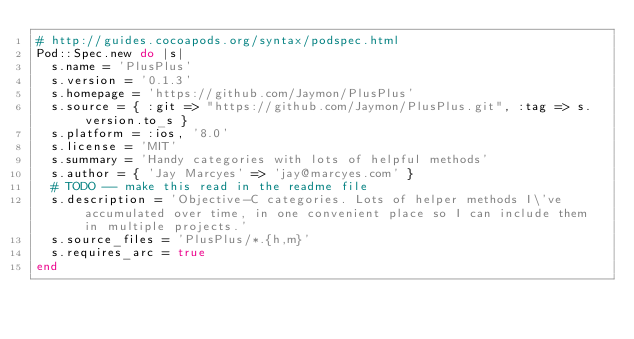<code> <loc_0><loc_0><loc_500><loc_500><_Ruby_># http://guides.cocoapods.org/syntax/podspec.html
Pod::Spec.new do |s|
  s.name = 'PlusPlus'
  s.version = '0.1.3'
  s.homepage = 'https://github.com/Jaymon/PlusPlus'
  s.source = { :git => "https://github.com/Jaymon/PlusPlus.git", :tag => s.version.to_s }
  s.platform = :ios, '8.0'
  s.license = 'MIT'
  s.summary = 'Handy categories with lots of helpful methods'
  s.author = { 'Jay Marcyes' => 'jay@marcyes.com' }
  # TODO -- make this read in the readme file
  s.description = 'Objective-C categories. Lots of helper methods I\'ve accumulated over time, in one convenient place so I can include them in multiple projects.'
  s.source_files = 'PlusPlus/*.{h,m}'
  s.requires_arc = true
end
</code> 